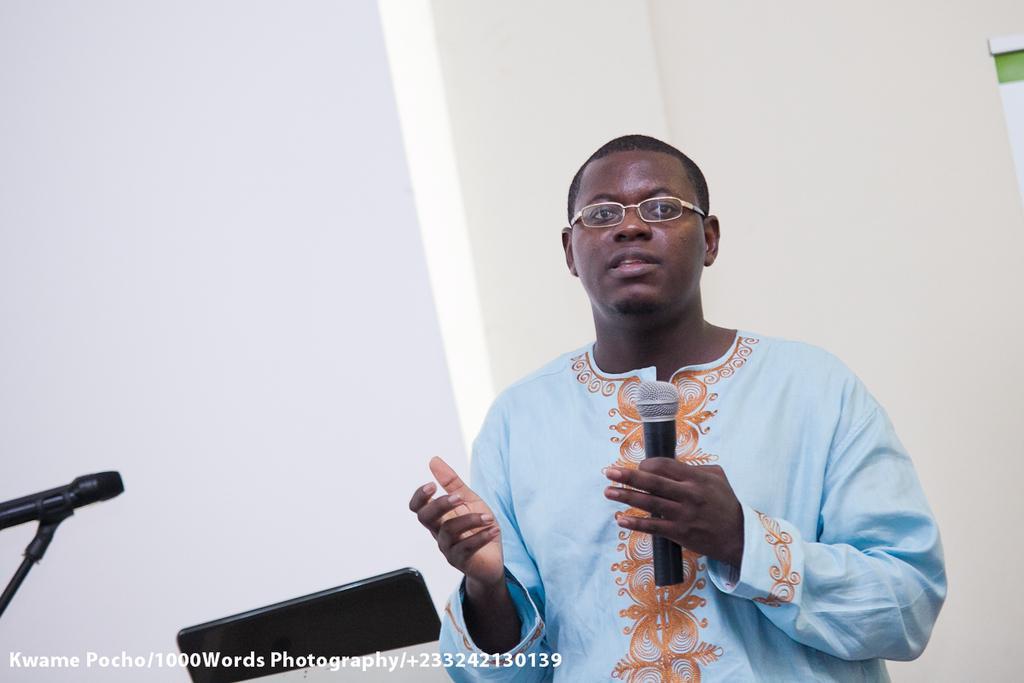Describe this image in one or two sentences. As we can see in the image there is a man holding mic. 